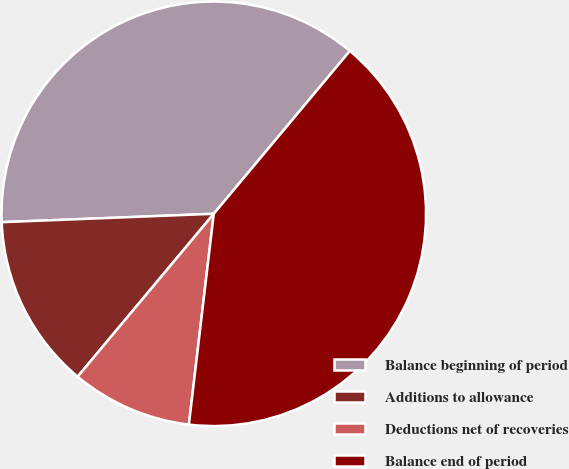<chart> <loc_0><loc_0><loc_500><loc_500><pie_chart><fcel>Balance beginning of period<fcel>Additions to allowance<fcel>Deductions net of recoveries<fcel>Balance end of period<nl><fcel>36.71%<fcel>13.29%<fcel>9.21%<fcel>40.79%<nl></chart> 